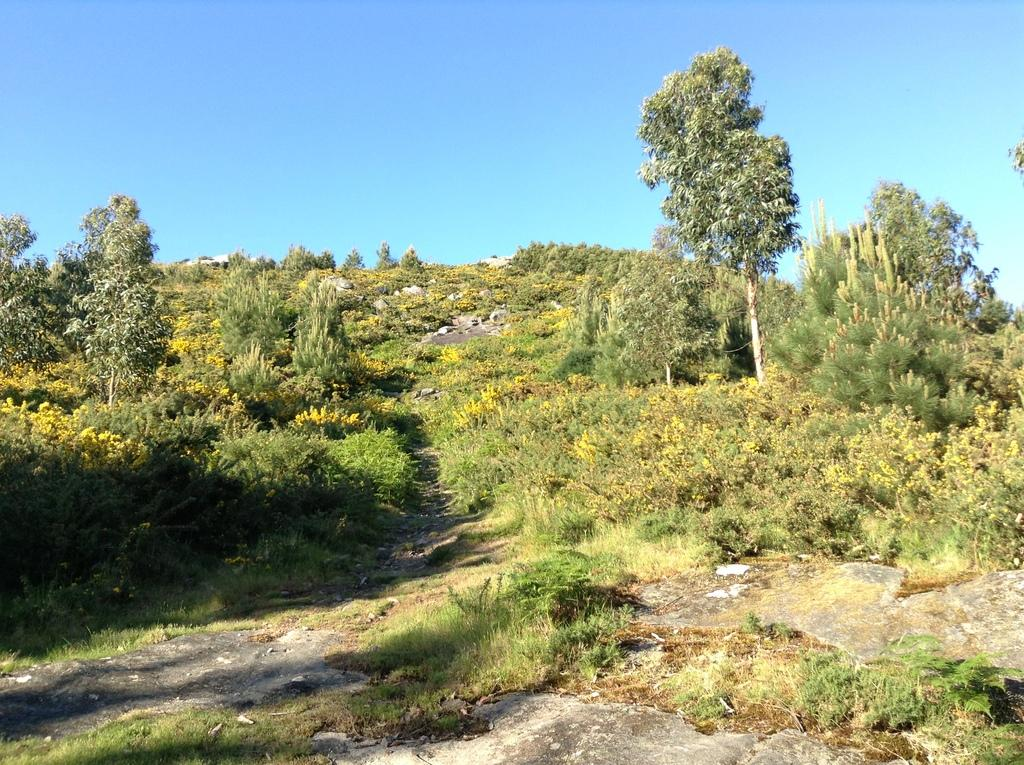What type of surface can be seen in the image? The ground is visible in the image. What type of vegetation is present in the image? There is grass, plants, and trees in the image. What other natural elements can be seen in the image? There are rocks in the image. What is visible above the ground and vegetation in the image? The sky is visible in the image. What type of jam is being spread on the rocks in the image? There is no jam present in the image; it features natural elements such as grass, plants, trees, rocks, and the sky. What direction is the train moving in the image? There is no train present in the image. 